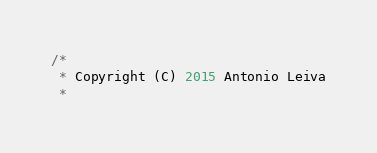<code> <loc_0><loc_0><loc_500><loc_500><_Java_>/*
 * Copyright (C) 2015 Antonio Leiva
 *</code> 